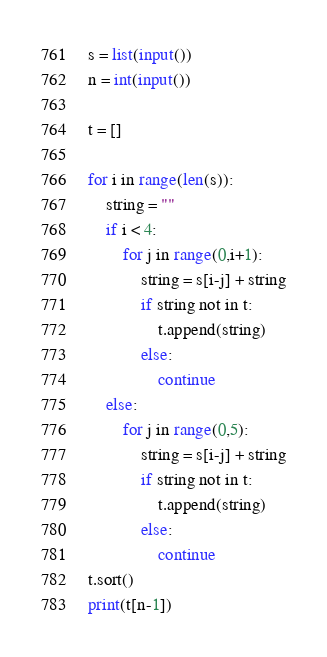Convert code to text. <code><loc_0><loc_0><loc_500><loc_500><_Python_>s = list(input())
n = int(input())

t = []

for i in range(len(s)):
    string = ""
    if i < 4:
        for j in range(0,i+1):
            string = s[i-j] + string
            if string not in t:
                t.append(string)
            else:
                continue
    else:
        for j in range(0,5):
            string = s[i-j] + string
            if string not in t:
                t.append(string)
            else:
                continue
t.sort()
print(t[n-1])</code> 